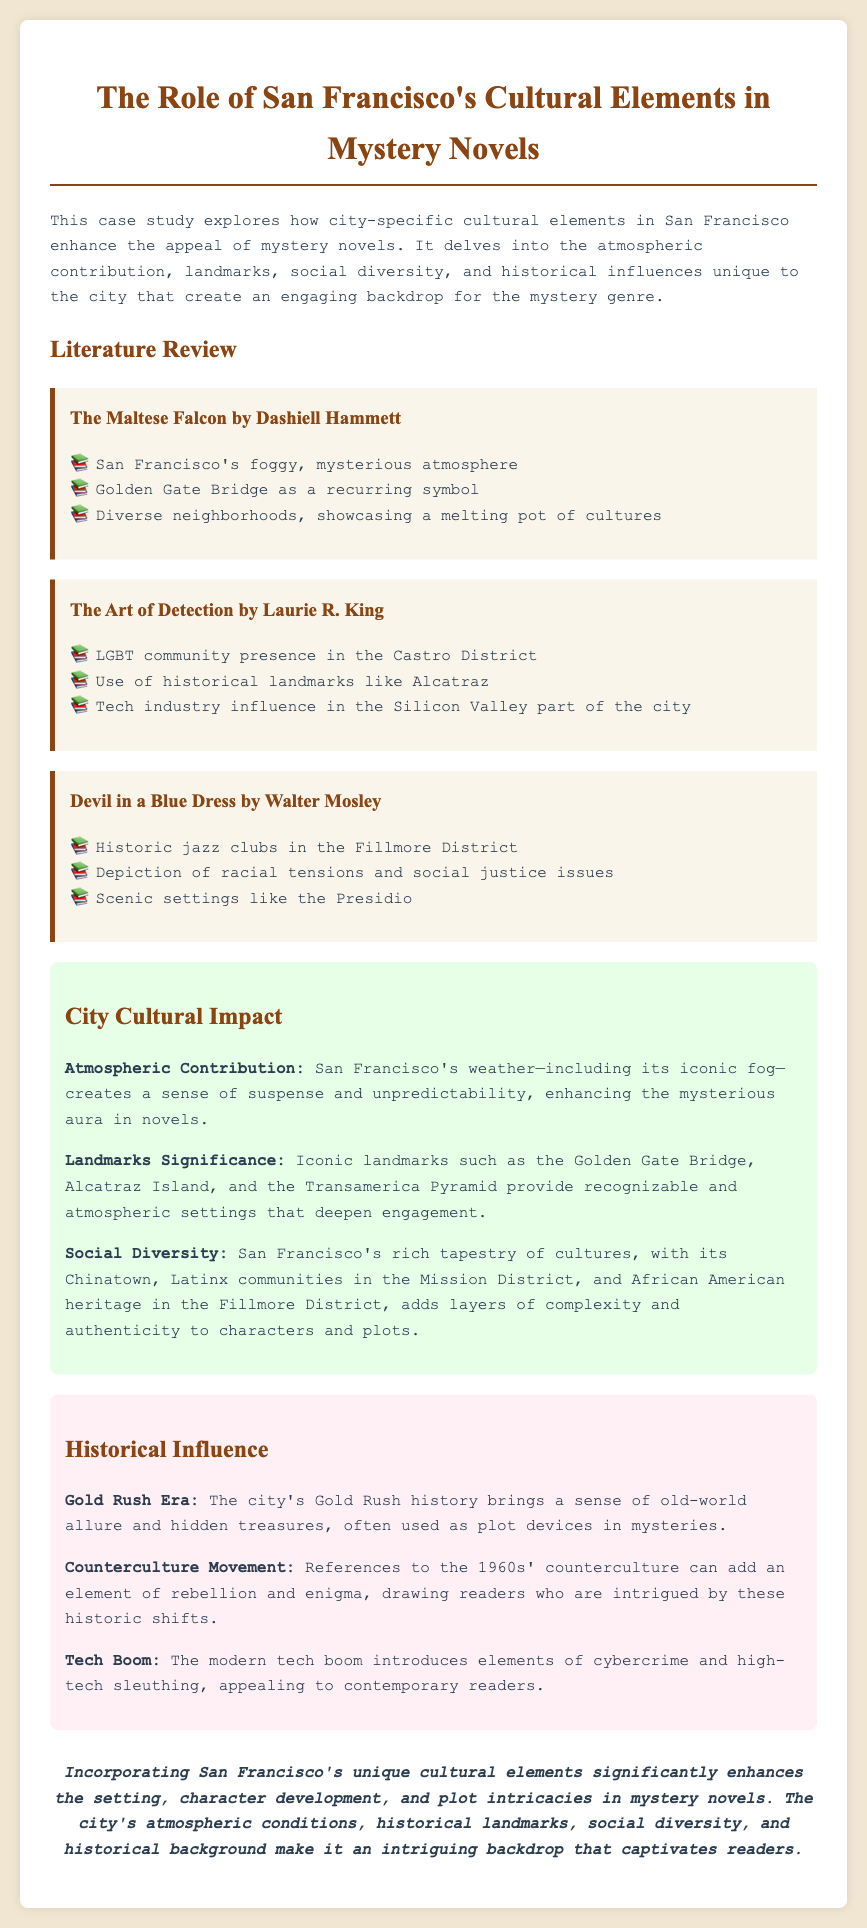What is the title of the first book mentioned? The first book mentioned in the document is detailed under the heading of "Literature Review," which is "The Maltese Falcon by Dashiell Hammett."
Answer: The Maltese Falcon by Dashiell Hammett What cultural element is associated with the Castro District? The document states that the Castro District is associated with the presence of the LGBT community in "The Art of Detection by Laurie R. King."
Answer: LGBT community What is the atmospheric contribution highlighted in the case study? The case study emphasizes San Francisco's weather, particularly its iconic fog, as a contributor to suspense and unpredictability.
Answer: Fog How many books are discussed in total? The document lists three mystery novels in the Literature Review section.
Answer: Three Which historical era adds a sense of old-world allure to mysteries? The case study mentions the Gold Rush Era as a historical influence that brings old-world allure and hidden treasures to mystery plots.
Answer: Gold Rush Era What landmark is frequently mentioned as a plot setting? The Golden Gate Bridge is mentioned as a recurring symbol and significant setting in "The Maltese Falcon."
Answer: Golden Gate Bridge What social issue is depicted in "Devil in a Blue Dress"? The document mentions racial tensions and social justice issues as being depicted in "Devil in a Blue Dress."
Answer: Racial tensions What influence does the tech boom introduce to contemporary mysteries? The case study explains that the modern tech boom brings elements of cybercrime and high-tech sleuthing to appeal to readers.
Answer: Cybercrime What genre does this case study focus on? The document focuses on the mystery genre, exploring how city-specific elements enhance its appeal.
Answer: Mystery genre 